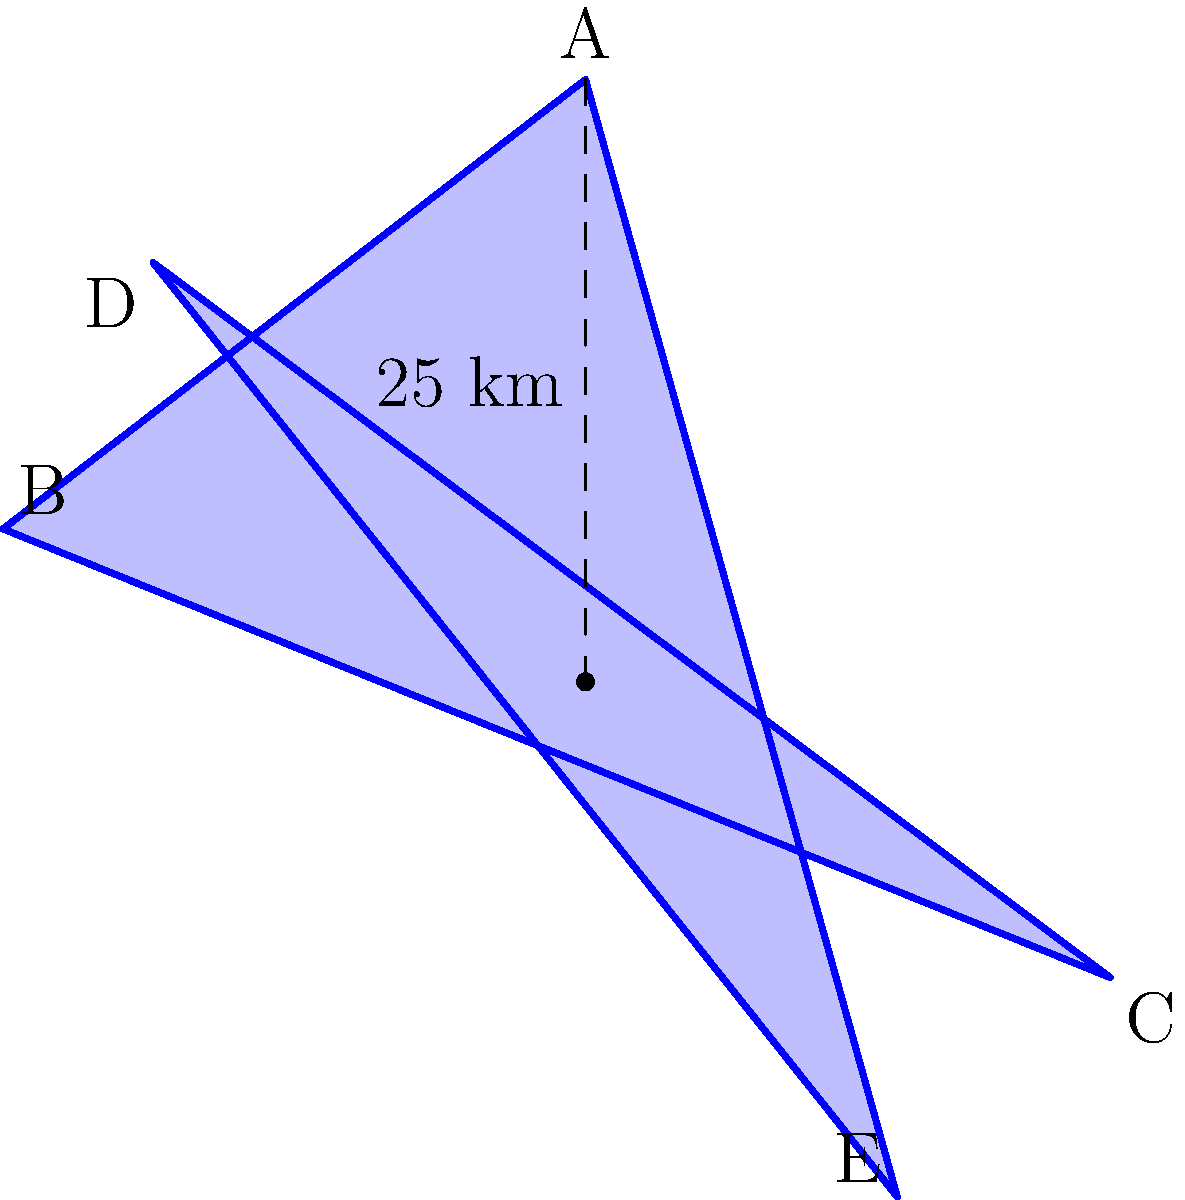A star-shaped region represents the reach of independent media networks in a Russian city. The star has 5 equal points, with each point 25 km from the center. Calculate the area of this star-shaped region to determine the total coverage area of these networks. Round your answer to the nearest whole number. To calculate the area of the star-shaped region, we'll follow these steps:

1) The star can be divided into 10 congruent triangles.

2) Let's focus on one of these triangles. It has:
   - Base: $25 \cdot \sin(36°)$ km (half the distance between two adjacent points)
   - Height: 25 km

3) The area of this triangle is:
   $A_{triangle} = \frac{1}{2} \cdot base \cdot height$
   $A_{triangle} = \frac{1}{2} \cdot (25 \cdot \sin(36°)) \cdot 25$

4) Now, we multiply this by 10 to get the total area:
   $A_{total} = 10 \cdot \frac{1}{2} \cdot (25 \cdot \sin(36°)) \cdot 25$
   $A_{total} = 125^2 \cdot 5 \cdot \sin(36°)$

5) Calculate:
   $\sin(36°) \approx 0.5878$
   $A_{total} \approx 125^2 \cdot 5 \cdot 0.5878 \approx 459.8$ sq km

6) Rounding to the nearest whole number: 460 sq km

This area represents the total coverage of independent media networks in the city, highlighting the reach of alternative information sources in Russian urban areas.
Answer: 460 sq km 